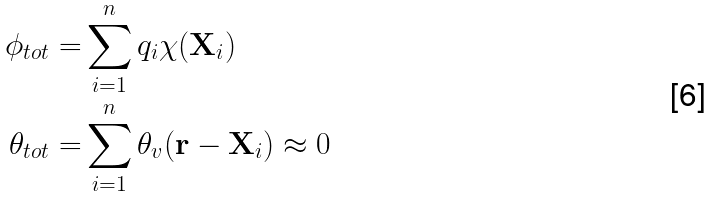<formula> <loc_0><loc_0><loc_500><loc_500>\phi _ { t o t } = & \sum _ { i = 1 } ^ { n } q _ { i } \chi ( \mathbf X _ { i } ) \\ \theta _ { t o t } = & \sum _ { i = 1 } ^ { n } \theta _ { v } ( \mathbf r - \mathbf X _ { i } ) \approx 0</formula> 